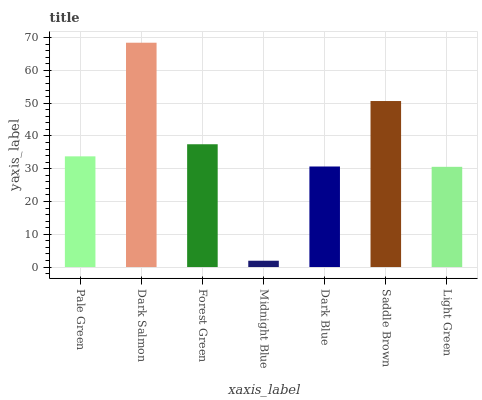Is Midnight Blue the minimum?
Answer yes or no. Yes. Is Dark Salmon the maximum?
Answer yes or no. Yes. Is Forest Green the minimum?
Answer yes or no. No. Is Forest Green the maximum?
Answer yes or no. No. Is Dark Salmon greater than Forest Green?
Answer yes or no. Yes. Is Forest Green less than Dark Salmon?
Answer yes or no. Yes. Is Forest Green greater than Dark Salmon?
Answer yes or no. No. Is Dark Salmon less than Forest Green?
Answer yes or no. No. Is Pale Green the high median?
Answer yes or no. Yes. Is Pale Green the low median?
Answer yes or no. Yes. Is Dark Salmon the high median?
Answer yes or no. No. Is Dark Salmon the low median?
Answer yes or no. No. 